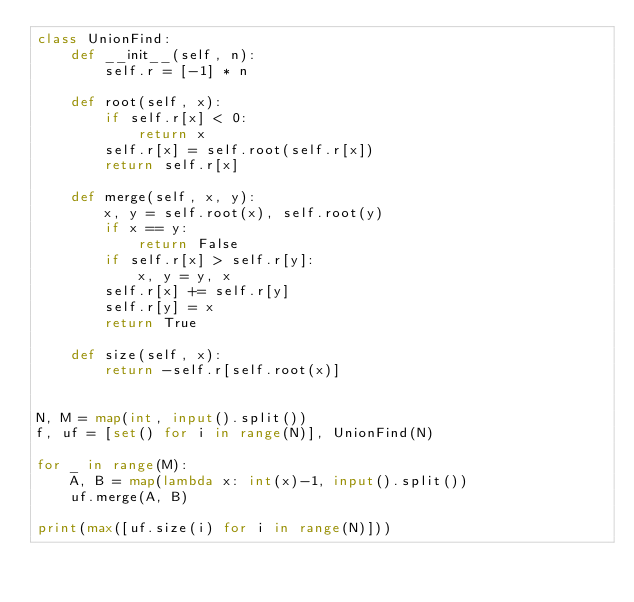Convert code to text. <code><loc_0><loc_0><loc_500><loc_500><_Python_>class UnionFind:
    def __init__(self, n):
        self.r = [-1] * n
    
    def root(self, x):
        if self.r[x] < 0:
            return x
        self.r[x] = self.root(self.r[x])
        return self.r[x]

    def merge(self, x, y):
        x, y = self.root(x), self.root(y)
        if x == y:
            return False
        if self.r[x] > self.r[y]:
            x, y = y, x
        self.r[x] += self.r[y]
        self.r[y] = x
        return True

    def size(self, x):
        return -self.r[self.root(x)]


N, M = map(int, input().split())
f, uf = [set() for i in range(N)], UnionFind(N)

for _ in range(M):
    A, B = map(lambda x: int(x)-1, input().split())
    uf.merge(A, B)

print(max([uf.size(i) for i in range(N)]))
</code> 